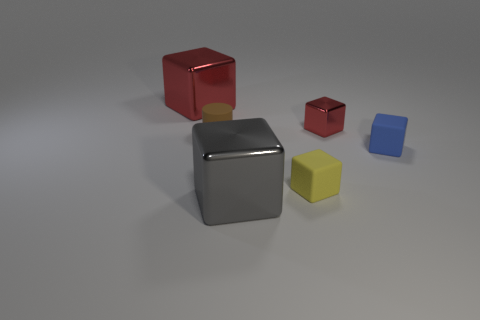There is a matte object that is in front of the blue object; is it the same size as the matte thing that is behind the tiny blue rubber cube?
Your answer should be compact. Yes. There is a small brown object in front of the big metal thing left of the large gray shiny cube; what is its shape?
Your answer should be very brief. Cylinder. Is the number of tiny yellow rubber things that are to the left of the big red metallic block the same as the number of tiny blocks?
Provide a short and direct response. No. What material is the big thing in front of the tiny rubber cylinder on the left side of the rubber block right of the small yellow cube made of?
Make the answer very short. Metal. Is there a green matte ball of the same size as the yellow block?
Offer a very short reply. No. There is a yellow object; what shape is it?
Give a very brief answer. Cube. How many spheres are yellow rubber objects or tiny red things?
Your answer should be compact. 0. Are there an equal number of tiny rubber things that are behind the small red cube and big gray cubes in front of the large gray metallic object?
Provide a short and direct response. Yes. There is a red block that is in front of the red metallic object to the left of the yellow thing; what number of matte objects are to the right of it?
Ensure brevity in your answer.  1. There is another object that is the same color as the small metal thing; what shape is it?
Give a very brief answer. Cube. 